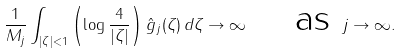Convert formula to latex. <formula><loc_0><loc_0><loc_500><loc_500>\frac { 1 } { M _ { j } } \int _ { | \zeta | < 1 } \left ( \log \frac { 4 } { | \zeta | } \right ) \hat { g } _ { j } ( \zeta ) \, d \zeta \to \infty \quad \text { as } j \to \infty .</formula> 